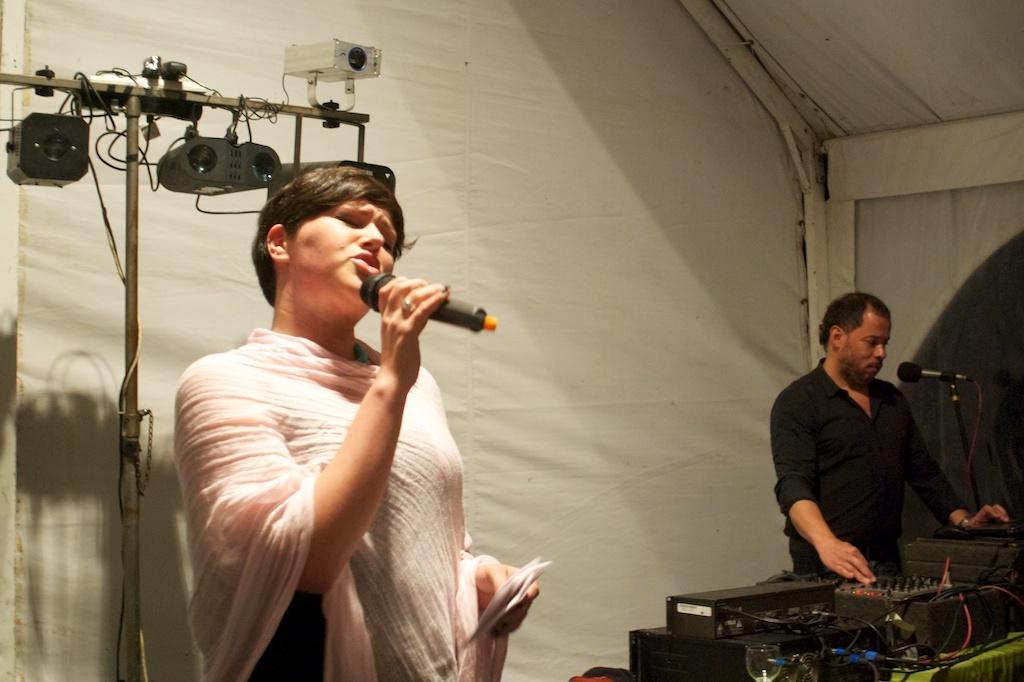In one or two sentences, can you explain what this image depicts? In this image I can see two people standing. One person is in front of disc jockey and another person is holding the mic and these people are under the tent. At the back there are camera attached to the stand. 